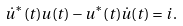Convert formula to latex. <formula><loc_0><loc_0><loc_500><loc_500>\dot { u } ^ { * } ( t ) u ( t ) - u ^ { * } ( t ) \dot { u } ( t ) = i .</formula> 